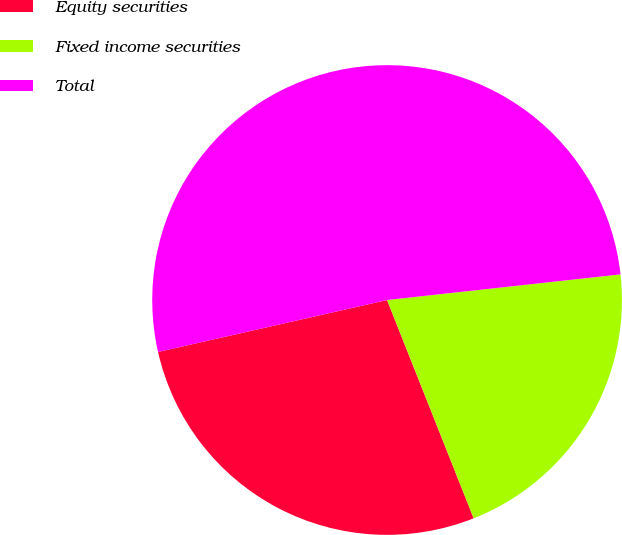<chart> <loc_0><loc_0><loc_500><loc_500><pie_chart><fcel>Equity securities<fcel>Fixed income securities<fcel>Total<nl><fcel>27.46%<fcel>20.73%<fcel>51.81%<nl></chart> 